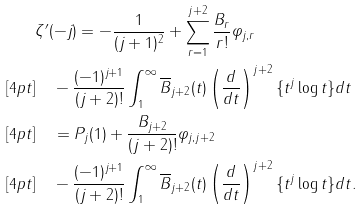<formula> <loc_0><loc_0><loc_500><loc_500>& \zeta ^ { \prime } ( - j ) = - \frac { 1 } { ( j + 1 ) ^ { 2 } } + \sum _ { r = 1 } ^ { j + 2 } \frac { B _ { r } } { r ! } \varphi _ { j , r } \\ [ 4 p t ] & \quad - \frac { ( - 1 ) ^ { j + 1 } } { ( j + 2 ) ! } \int _ { 1 } ^ { \infty } \overline { B } _ { j + 2 } ( t ) \left ( \frac { d } { d t } \right ) ^ { j + 2 } \{ t ^ { j } \log t \} d t \\ [ 4 p t ] & \quad = P _ { j } ( 1 ) + \frac { B _ { j + 2 } } { ( j + 2 ) ! } \varphi _ { j , j + 2 } \\ [ 4 p t ] & \quad - \frac { ( - 1 ) ^ { j + 1 } } { ( j + 2 ) ! } \int _ { 1 } ^ { \infty } \overline { B } _ { j + 2 } ( t ) \left ( \frac { d } { d t } \right ) ^ { j + 2 } \{ t ^ { j } \log t \} d t .</formula> 